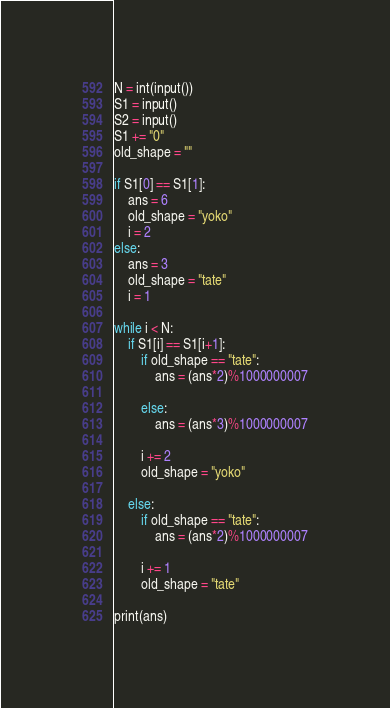<code> <loc_0><loc_0><loc_500><loc_500><_Python_>
N = int(input())
S1 = input()
S2 = input()
S1 += "0"
old_shape = ""

if S1[0] == S1[1]:
    ans = 6
    old_shape = "yoko"
    i = 2
else:
    ans = 3
    old_shape = "tate"
    i = 1

while i < N:
    if S1[i] == S1[i+1]:
        if old_shape == "tate":
            ans = (ans*2)%1000000007
            
        else:
            ans = (ans*3)%1000000007
            
        i += 2
        old_shape = "yoko"
    
    else:
        if old_shape == "tate":
            ans = (ans*2)%1000000007
        
        i += 1
        old_shape = "tate"

print(ans)</code> 